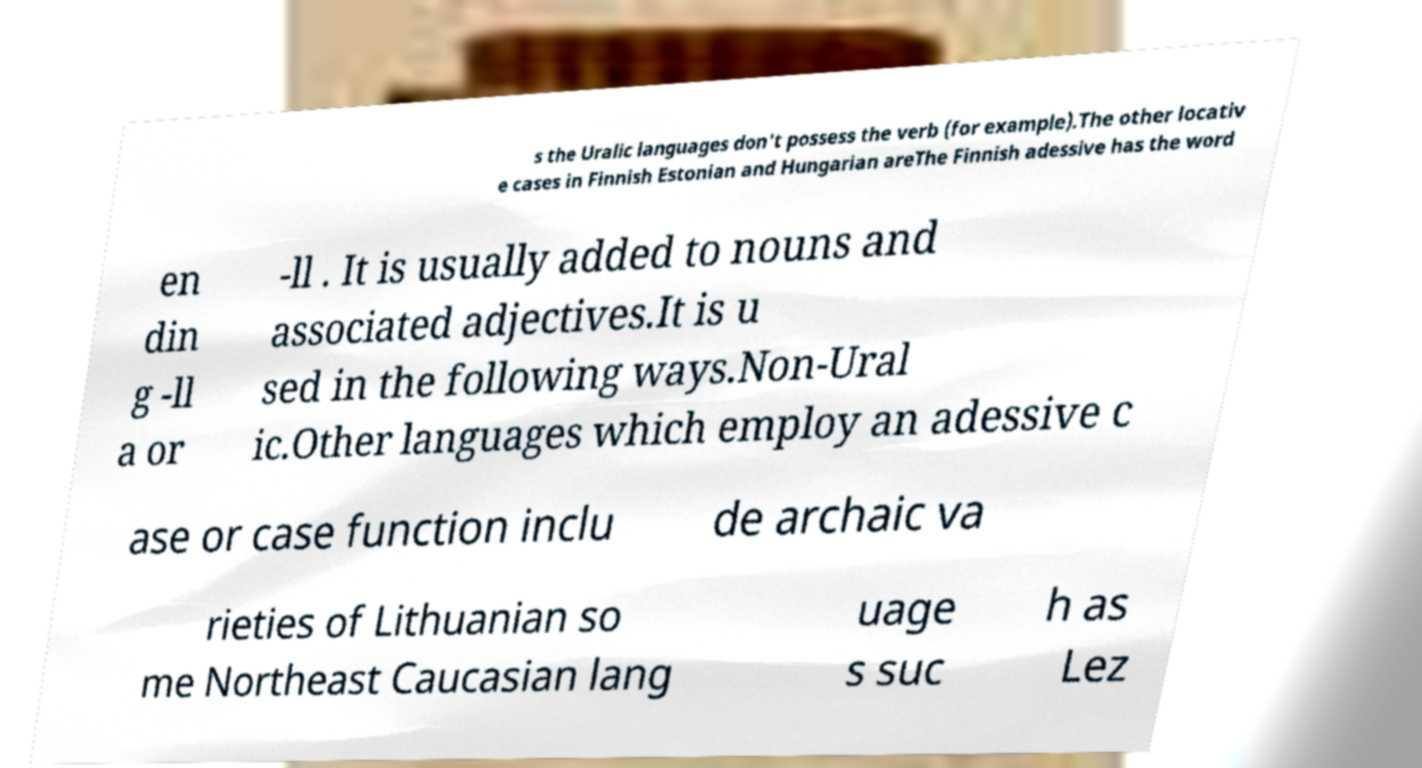Can you accurately transcribe the text from the provided image for me? s the Uralic languages don't possess the verb (for example).The other locativ e cases in Finnish Estonian and Hungarian areThe Finnish adessive has the word en din g -ll a or -ll . It is usually added to nouns and associated adjectives.It is u sed in the following ways.Non-Ural ic.Other languages which employ an adessive c ase or case function inclu de archaic va rieties of Lithuanian so me Northeast Caucasian lang uage s suc h as Lez 